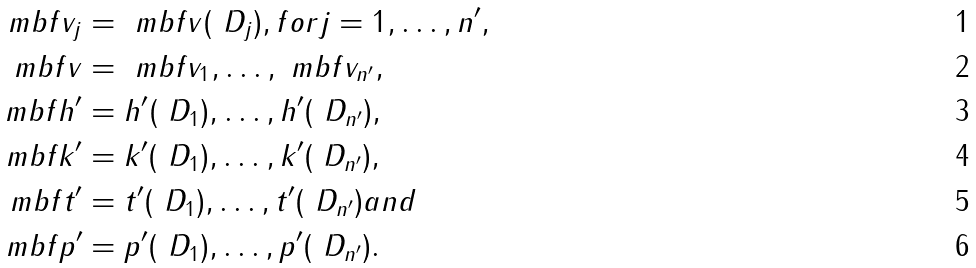<formula> <loc_0><loc_0><loc_500><loc_500>\ m b f v _ { j } & = \ m b f v ( \ D _ { j } ) , f o r j = 1 , \dots , n ^ { \prime } , \\ \ m b f v & = \ m b f v _ { 1 } , \dots , \ m b f v _ { n ^ { \prime } } , \\ \ m b f h ^ { \prime } & = h ^ { \prime } ( \ D _ { 1 } ) , \dots , h ^ { \prime } ( \ D _ { n ^ { \prime } } ) , \\ \ m b f k ^ { \prime } & = k ^ { \prime } ( \ D _ { 1 } ) , \dots , k ^ { \prime } ( \ D _ { n ^ { \prime } } ) , \\ \ m b f t ^ { \prime } & = t ^ { \prime } ( \ D _ { 1 } ) , \dots , t ^ { \prime } ( \ D _ { n ^ { \prime } } ) a n d \\ \ m b f p ^ { \prime } & = p ^ { \prime } ( \ D _ { 1 } ) , \dots , p ^ { \prime } ( \ D _ { n ^ { \prime } } ) .</formula> 